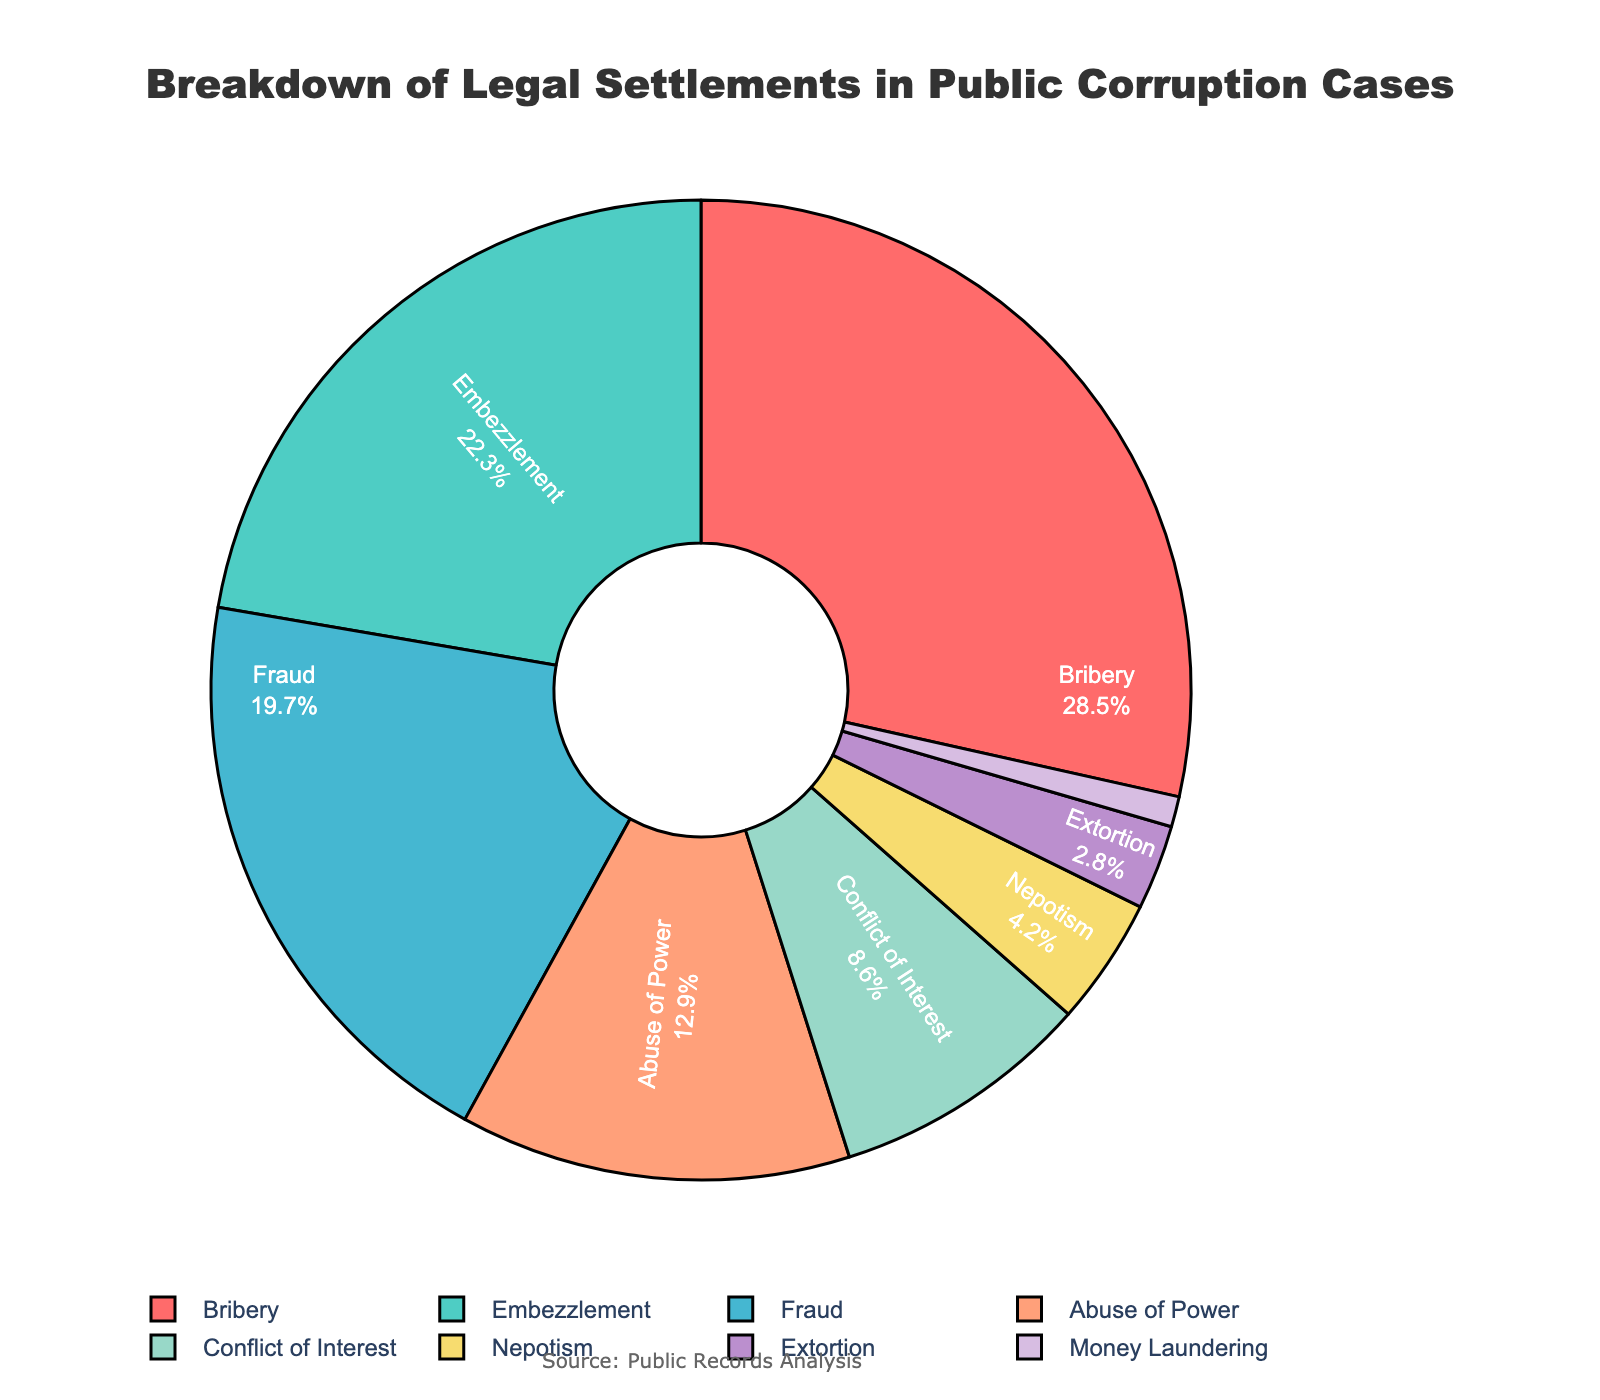What's the most common type of misconduct in legal settlements for public corruption cases? By looking at the pie chart, the largest section represents Bribery at 28.5%.
Answer: Bribery Which type of misconduct accounts for the smallest percentage of legal settlements? The smallest section in the pie chart is Money Laundering, with 1.0%.
Answer: Money Laundering What is the combined percentage of Embezzlement and Fraud? Embezzlement has 22.3% and Fraud has 19.7%. Adding them together gives 22.3% + 19.7% = 42.0%.
Answer: 42.0% How does the percentage of Abuse of Power compare to Conflict of Interest? Abuse of Power holds 12.9% while Conflict of Interest holds 8.6%. 12.9% is greater than 8.6%.
Answer: Abuse of Power is greater What percentage do Nepotism and Extortion account for together? Nepotism has 4.2% and Extortion has 2.8%. Adding them together gives 4.2% + 2.8% = 7.0%.
Answer: 7.0% What is the difference in percentage between Bribery and Fraud? Bribery has 28.5% and Fraud has 19.7%. The difference is 28.5% - 19.7% = 8.8%.
Answer: 8.8% Which color represents Embezzlement in the pie chart? The second largest section corresponds to Embezzlement, which is colored in a shade of green.
Answer: Green How many types of misconducts have a percentage below 10%? By looking at the pie chart, Conflict of Interest (8.6%), Nepotism (4.2%), Extortion (2.8%), and Money Laundering (1.0%) all have percentages below 10%. There are 4 categories.
Answer: 4 What percentage do all types of misconduct except Bribery and Embezzlement account for? Excluding Bribery (28.5%) and Embezzlement (22.3%), the total percentage is calculated by adding the remaining percentages: 19.7% (Fraud) + 12.9% (Abuse of Power) + 8.6% (Conflict of Interest) + 4.2% (Nepotism) + 2.8% (Extortion) + 1.0% (Money Laundering) = 49.2%.
Answer: 49.2% What's the sum of the percentages of the two least common types of misconduct? The two least common types are Money Laundering (1.0%) and Extortion (2.8%). Their sum is 1.0% + 2.8% = 3.8%.
Answer: 3.8% 